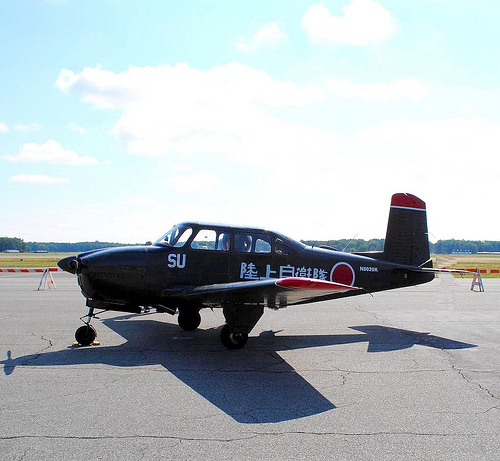Please provide a short description for this region: [0.39, 0.49, 0.46, 0.54]. This region shows a window on the plane, allowing passengers to view the outside sky and surroundings. 